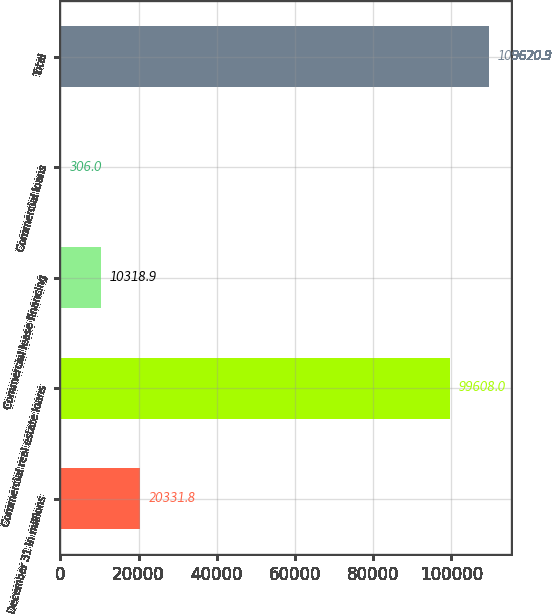<chart> <loc_0><loc_0><loc_500><loc_500><bar_chart><fcel>December 31 in millions<fcel>Commercial real estate loans<fcel>Commercial lease financing<fcel>Commercial loans<fcel>Total<nl><fcel>20331.8<fcel>99608<fcel>10318.9<fcel>306<fcel>109621<nl></chart> 